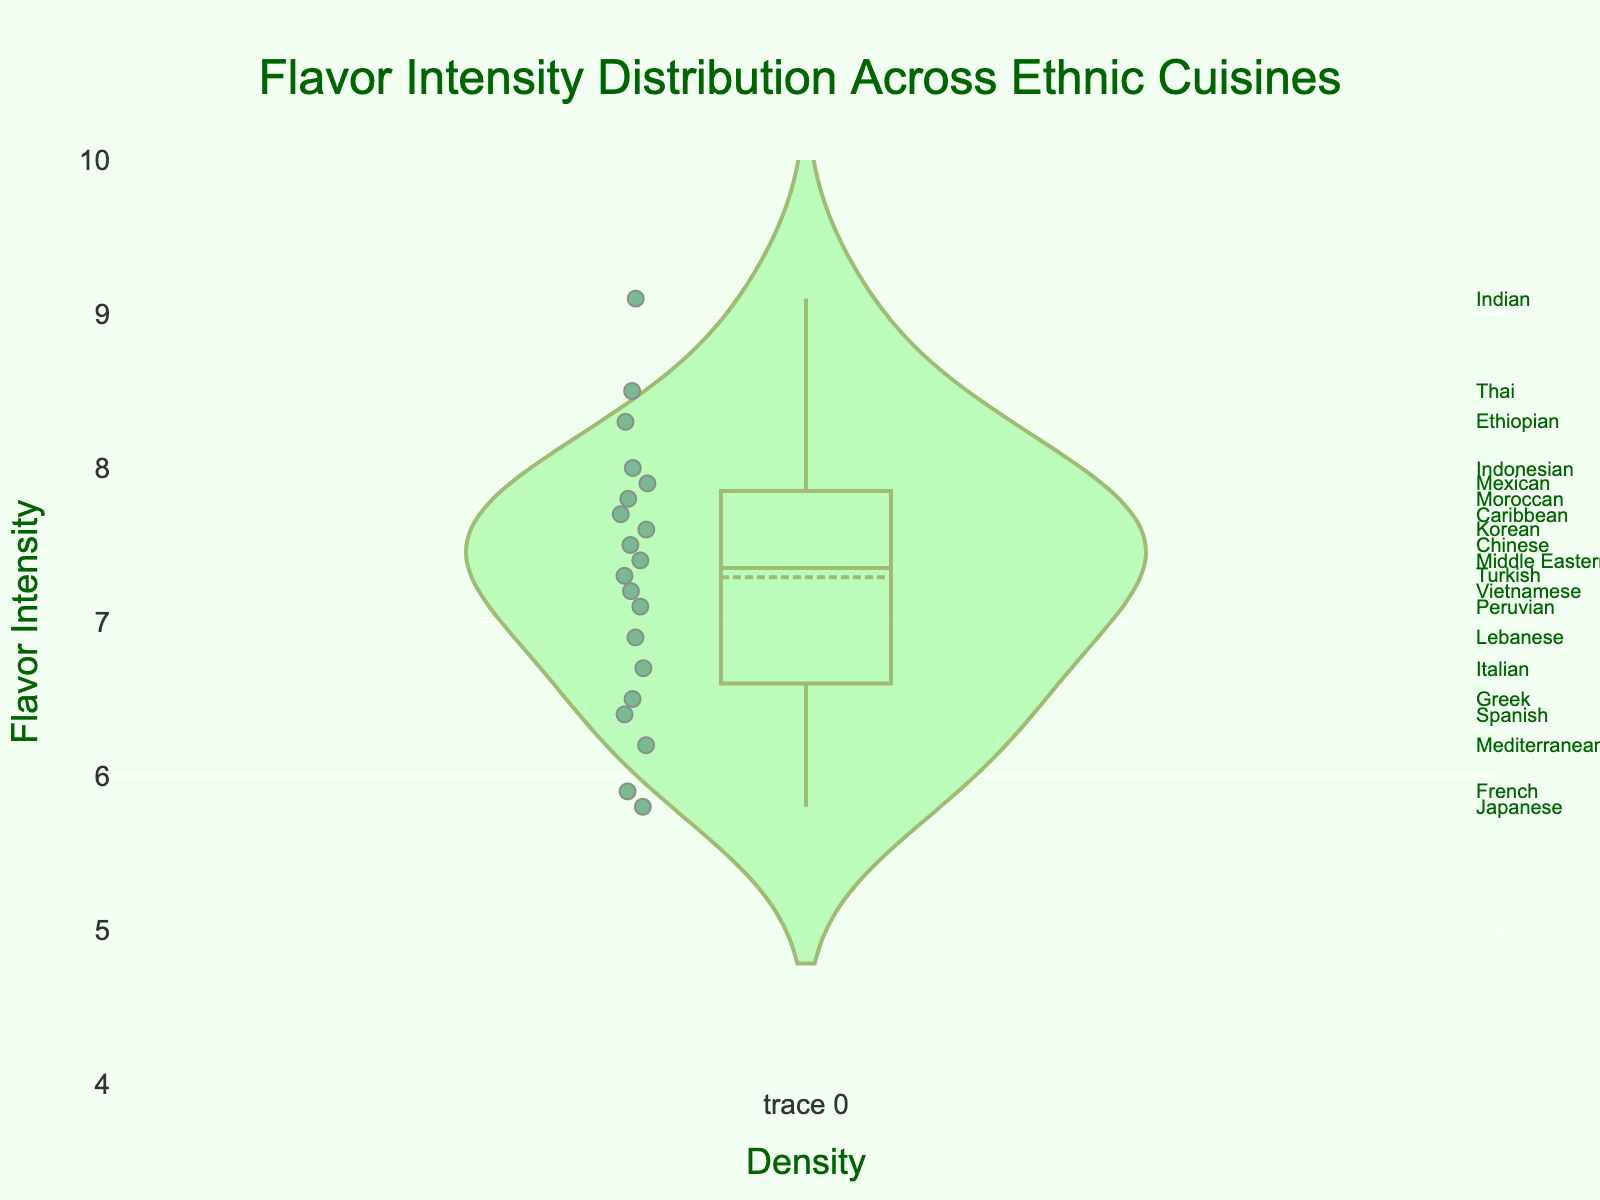What is the title of the plot? The title is usually located at the top center of the plot and is designed to give an overview of what the plot represents. In this case, it states, "Flavor Intensity Distribution Across Ethnic Cuisines."
Answer: Flavor Intensity Distribution Across Ethnic Cuisines What does the y-axis represent? The y-axis is labeled "Flavor Intensity," which indicates that it shows the range of flavor intensity values for various ethnic cuisines.
Answer: Flavor Intensity What is the range of the y-axis? The y-axis range is explicitly set between 4 and 10, ensuring all flavor intensity values are within this range. This can be inferred from the range markers provided by the axis.
Answer: 4 to 10 Which cuisine has the highest flavor intensity? By examining the highest point on the plot, we can identify that Indian cuisine has the highest flavor intensity, marked at 9.1.
Answer: Indian Which cuisine has the lowest flavor intensity? To find the lowest flavor intensity, we look at the bottom-most point on the plot, which is 5.8, corresponding to Japanese cuisine.
Answer: Japanese How many cuisines have a flavor intensity greater than 8? We need to identify and count all the data points that lie above the flavor intensity level of 8. These are Thai, Indian, Ethiopian, and Indonesian cuisines.
Answer: Four What is the average flavor intensity of these cuisines? To calculate the average flavor intensity, sum up all the flavor intensity values and divide by the number of cuisines. The total sum is 143.2, and there are 19 cuisines. So, the average = 143.2 / 19 ≈ 7.53.
Answer: 7.53 Which cuisines have a flavor intensity approximately around the average intensity? The average intensity is about 7.53. We identify Vietnamese (7.2), Mexican (7.9), Korean (7.6), Moroccan (7.8), Peruvian (7.1), Chinese (7.5), Turkish (7.3), Caribbean (7.7), and Middle Eastern (7.4) as being close to this value.
Answer: Vietnamese, Mexican, Korean, Moroccan, Peruvian, Chinese, Turkish, Caribbean, Middle Eastern How does Mediterranean cuisine's flavor intensity compare to that of Italian cuisine? Mediterranean cuisine has a flavor intensity of 6.2, while Italian cuisine has 6.7. By comparing these values: 6.2 is less than 6.7.
Answer: Mediterranean is less intense than Italian Based on the distribution, do more cuisines tend to have a higher or lower flavor intensity? By observing the spread and concentration of points and the density values, more data points appear to cluster around the higher end of the flavor intensity range (> 7) compared to the lower end (< 6).
Answer: Higher 